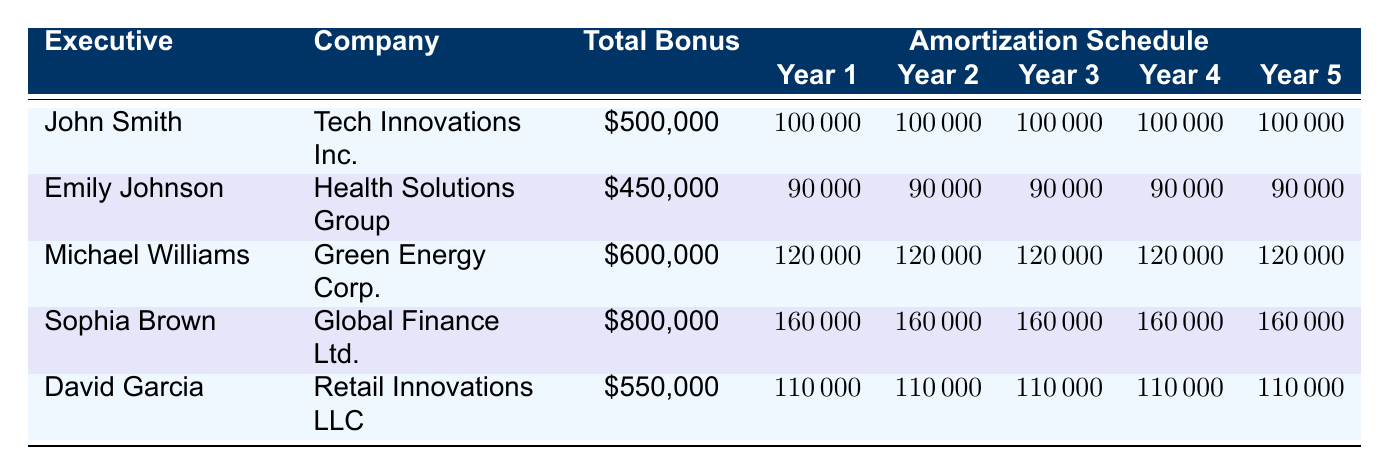What is the total incentive bonus for Sophia Brown? Sophia Brown's total incentive bonus is listed in the table adjacent to her name. It shows \$800,000.
Answer: 800000 How much does John Smith amortize in Year 3? The amount John Smith amortizes in Year 3 is indicated in the corresponding column for Year 3 in the table which shows \$100,000.
Answer: 100000 What is the average annual amortization amount for Michael Williams? Michael Williams has an incentive bonus of \$600,000, which he amortizes equally over 5 years. Thus, the average amount per year is \$120,000, calculated by dividing the total by 5.
Answer: 120000 Is Emily Johnson's total bonus greater than David Garcia's? Emily Johnson's total bonus is \$450,000 and David Garcia's total bonus is \$550,000. Since \$450,000 is less than \$550,000, the statement is false.
Answer: No What is the total amount of bonuses amortized in Year 1? To find the total for Year 1, add all the Year 1 amounts together: \$100,000 (John) + \$90,000 (Emily) + \$120,000 (Michael) + \$160,000 (Sophia) + \$110,000 (David) = \$580,000.
Answer: 580000 How much does Global Finance Ltd. amortize over the five years? Global Finance Ltd. amortizes \$160,000 per year for 5 years; therefore, the total is calculated as \$160,000 multiplied by 5, which equals \$800,000.
Answer: 800000 Do any executives amortize the same amount in Year 4? Looking at Year 4, we see that all executives amortize a different amount (John \$100,000, Emily \$90,000, Michael \$120,000, Sophia \$160,000, David \$110,000). Therefore, no two executives amortize the same amount in Year 4.
Answer: No What is the total incentive bonus amount for all executives combined? To calculate the total incentive bonus, sum all the bonuses: \$500,000 (John) + \$450,000 (Emily) + \$600,000 (Michael) + \$800,000 (Sophia) + \$550,000 (David) = \$2,900,000.
Answer: 2900000 Which executive has the highest yearly amortization amount? Examining the yearly amortization amounts, Sophia Brown, with \$160,000 per year, has the highest amount compared to other executives' yearly amounts.
Answer: Sophia Brown 